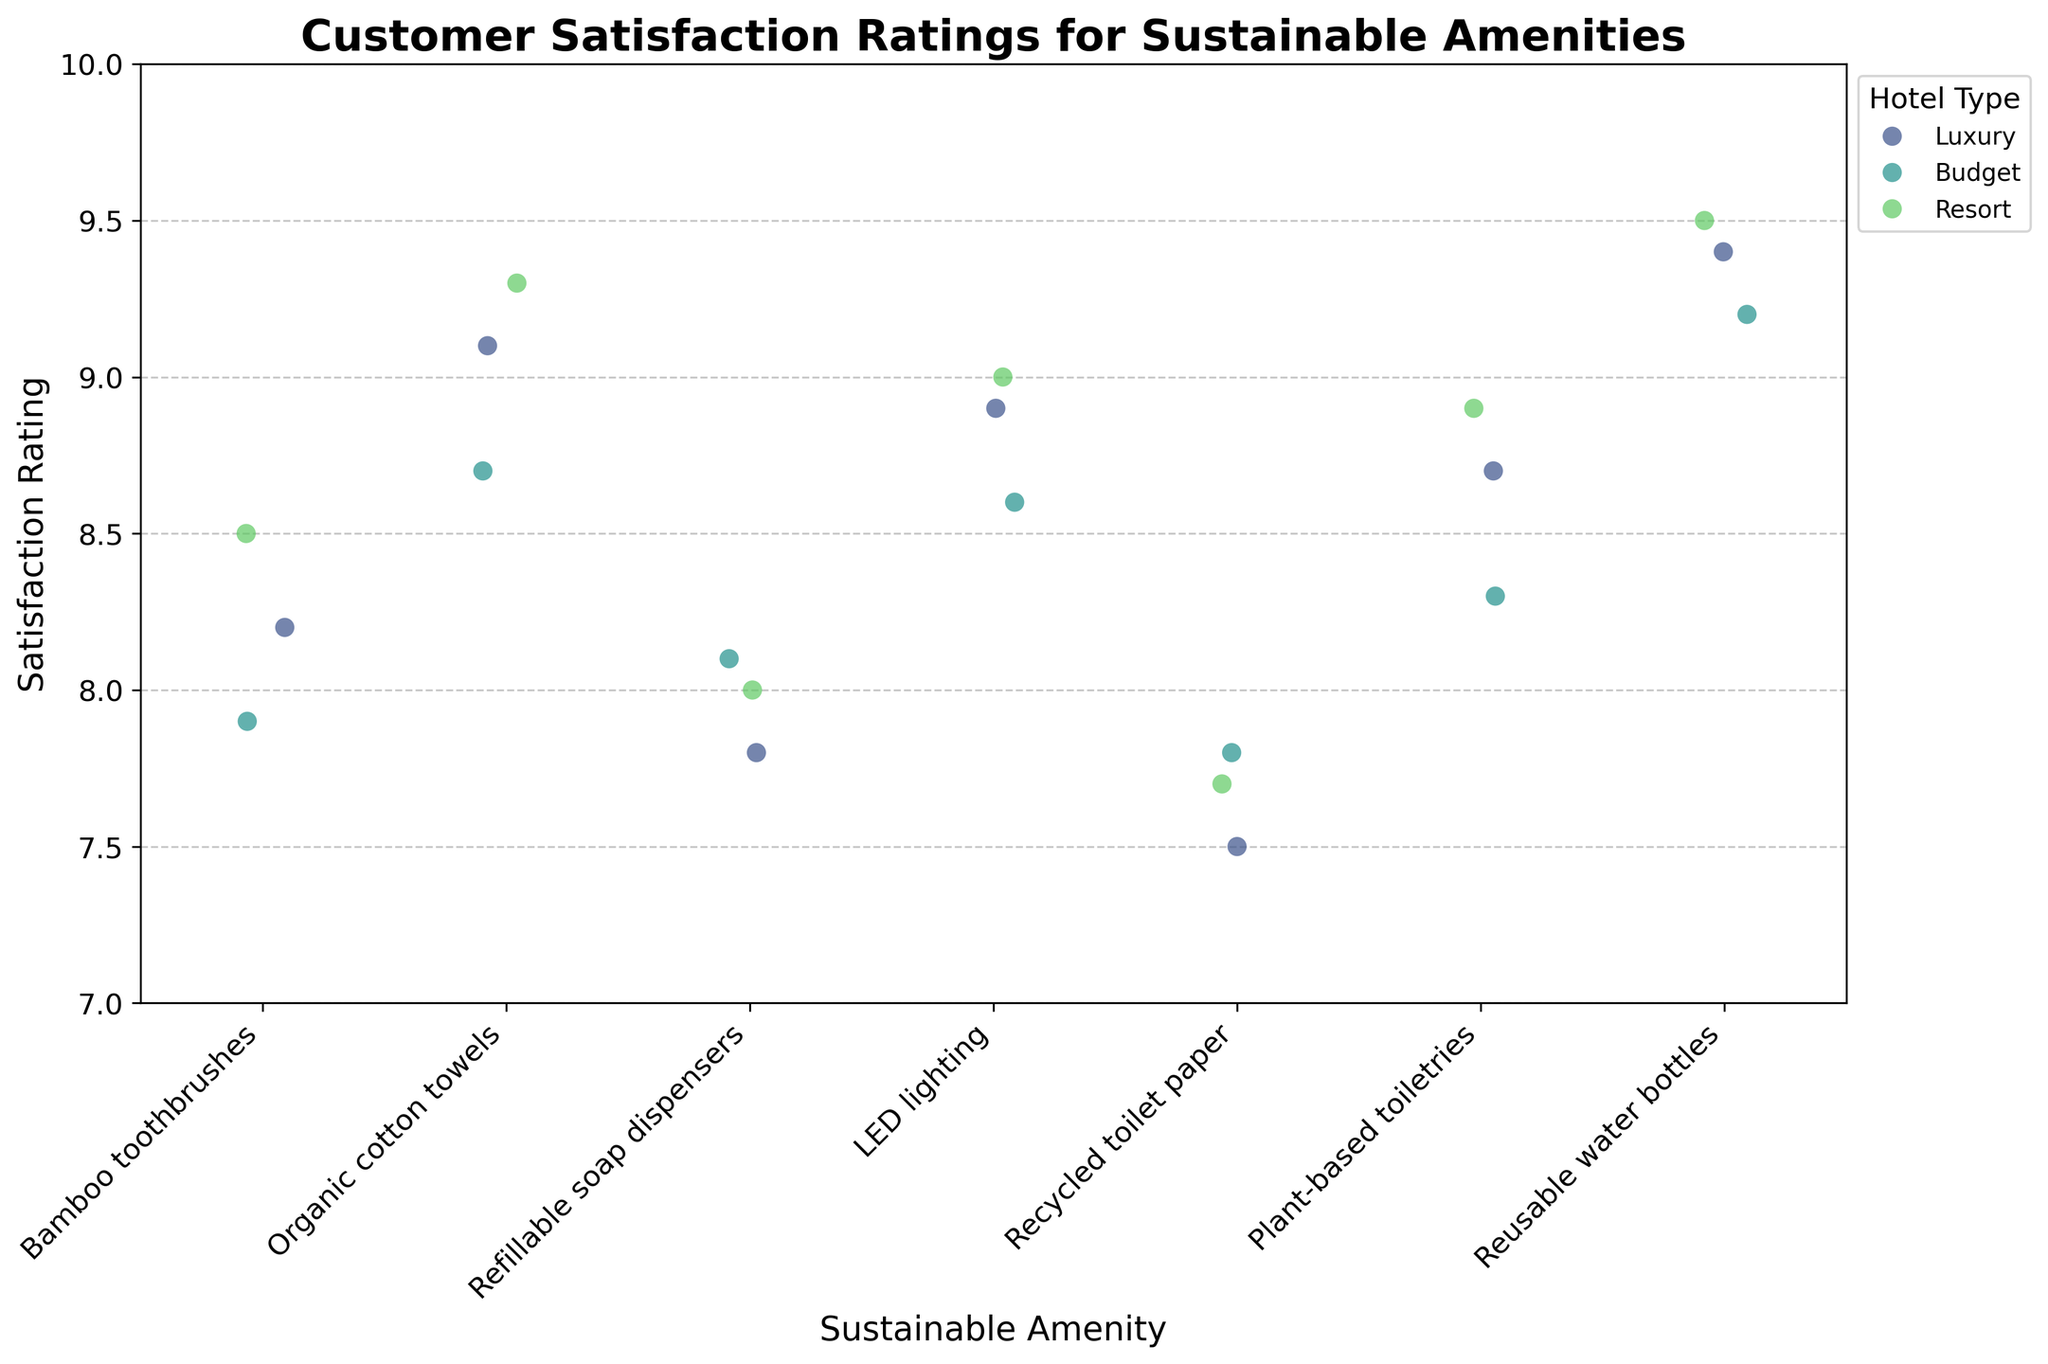What's the title of the plot? The title of the plot is written at the top of the figure and helps to understand what is being depicted. It reads "Customer Satisfaction Ratings for Sustainable Amenities".
Answer: Customer Satisfaction Ratings for Sustainable Amenities What is the y-axis label? The y-axis label is located along the vertical axis and describes what is being measured. It is labeled "Satisfaction Rating".
Answer: Satisfaction Rating Which sustainable amenity has the highest satisfaction rating for Luxury hotels? Identify the highest point along the y-axis within the cluster of 'Luxury' points for each amenity. Reusable water bottles have the highest satisfaction rating (9.4) for Luxury hotels.
Answer: Reusable water bottles For which hotel type is the satisfaction rating for "Refillable soap dispensers" the lowest? Compare the y-axis positions of 'Refillable soap dispensers' data points across different hotel types. The lowest satisfaction rating (7.8) for "Refillable soap dispensers" is seen in Luxury hotels.
Answer: Luxury Which sustainable amenity has the most uniform satisfaction ratings across all hotel types? Look for the amenity where data points are closest to each other across hotel types. "LED lighting" has very similar satisfaction ratings of 8.9, 8.6, and 9.0 for Luxury, Budget, and Resort hotels, respectively.
Answer: LED lighting How does the satisfaction rating for "Recycled toilet paper" in Budget hotels compare to that in Luxury hotels? Locate the satisfaction ratings for "Recycled toilet paper" for both Budget and Luxury hotels and compare. Budget hotels have a satisfaction rating of 7.8, which is higher than Luxury hotels, which have a rating of 7.5.
Answer: It is higher in Budget hotels Which hotel type generally has the highest satisfaction ratings for "Plant-based toiletries"? Evaluate the y-axis positions of 'Plant-based toiletries' points across all hotel types. The highest rating (8.9) is in Resort hotels.
Answer: Resort What is the average satisfaction rating for "Organic cotton towels" across all hotel types? Sum the satisfaction ratings for "Organic cotton towels" and divide by the number of hotel types. The average is (9.1 + 8.7 + 9.3)/3 = 9.03.
Answer: 9.03 Which sustainable amenity has the lowest satisfaction rating for Resort hotels? Locate the lowest point along the y-axis within the 'Resort' points for each amenity. "Recycled toilet paper" has the lowest satisfaction rating (7.7) in Resort hotels.
Answer: Recycled toilet paper Is there any sustainable amenity that has a perfect satisfaction rating of 10? Look along the y-axis for any data points at the rating of 10. There are no data points that reach a perfect rating of 10.
Answer: No 